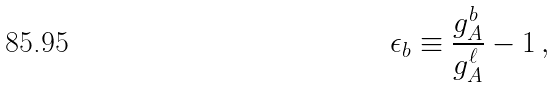<formula> <loc_0><loc_0><loc_500><loc_500>\epsilon _ { b } \equiv \frac { g ^ { b } _ { A } } { g ^ { \ell } _ { A } } - 1 \, ,</formula> 